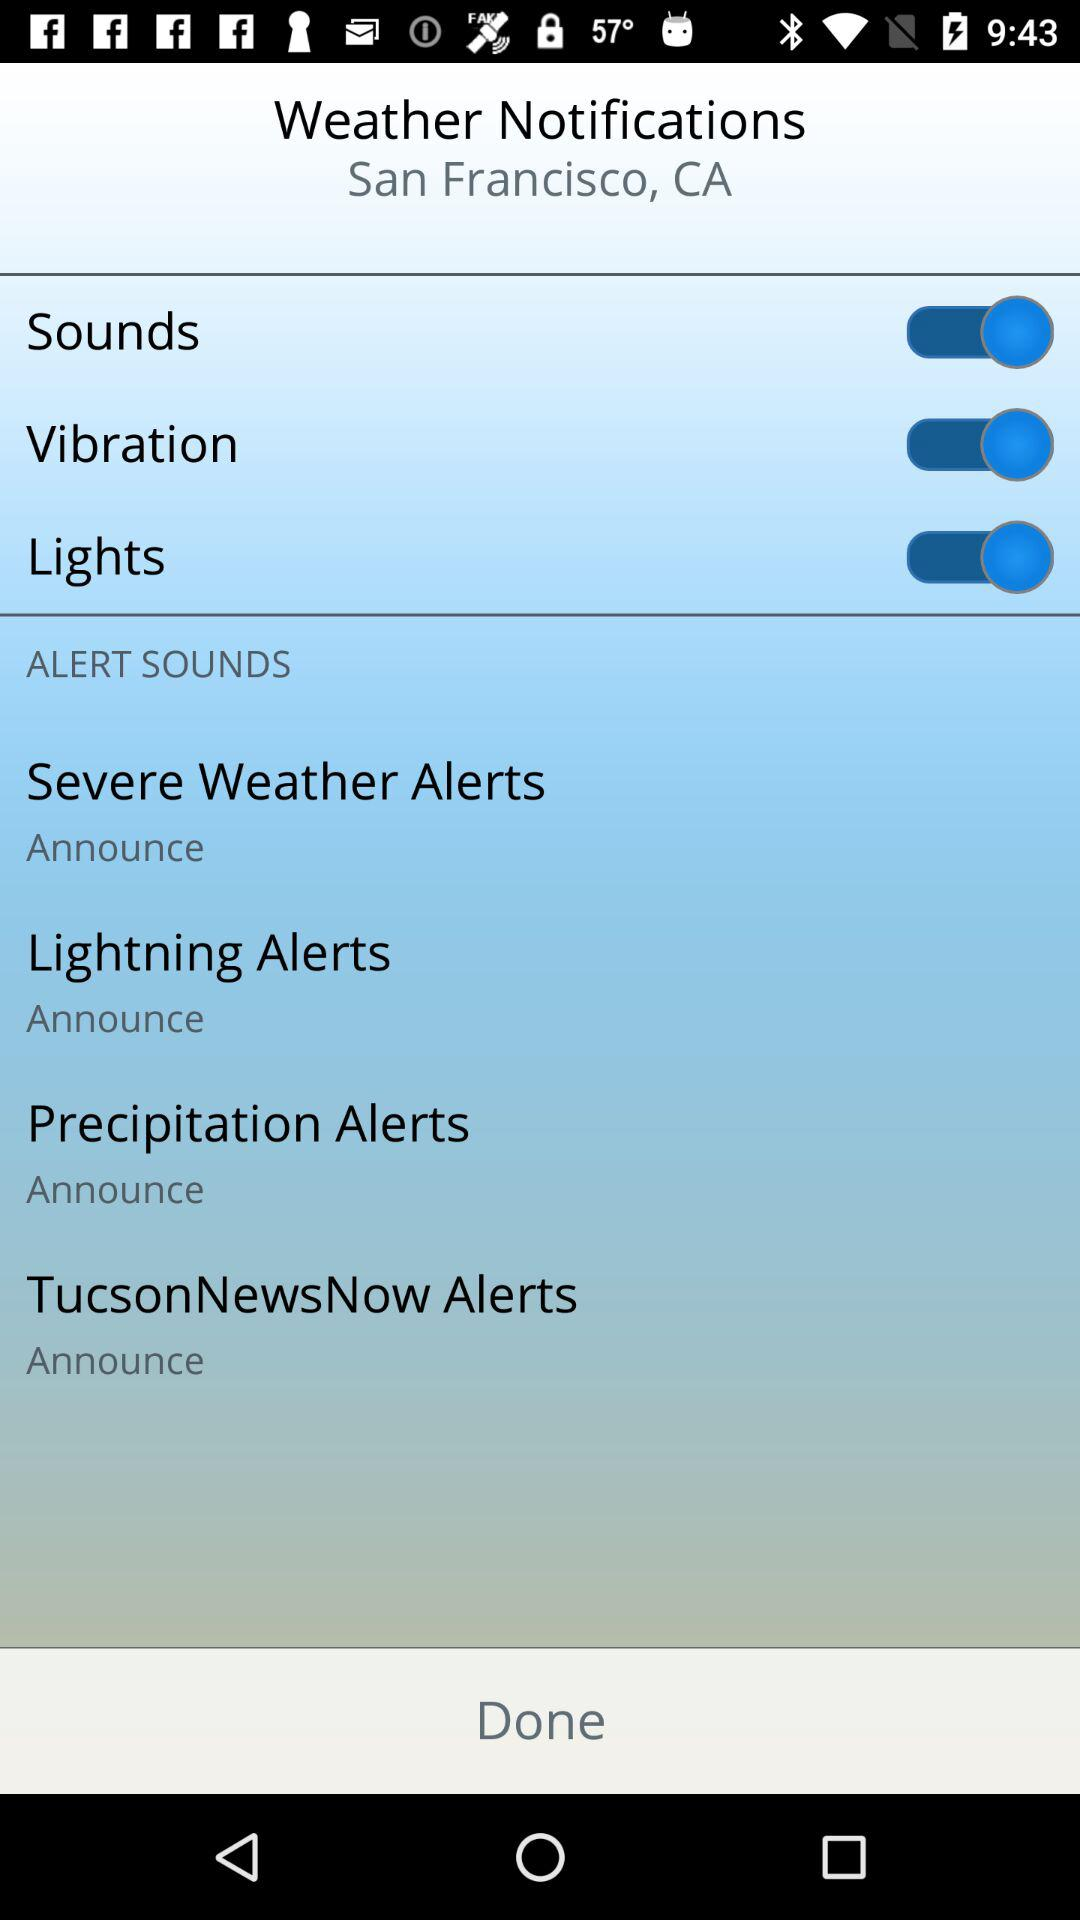What is the setting for the lightning alerts notification? The setting for the lightning alerts notification is "Announce". 